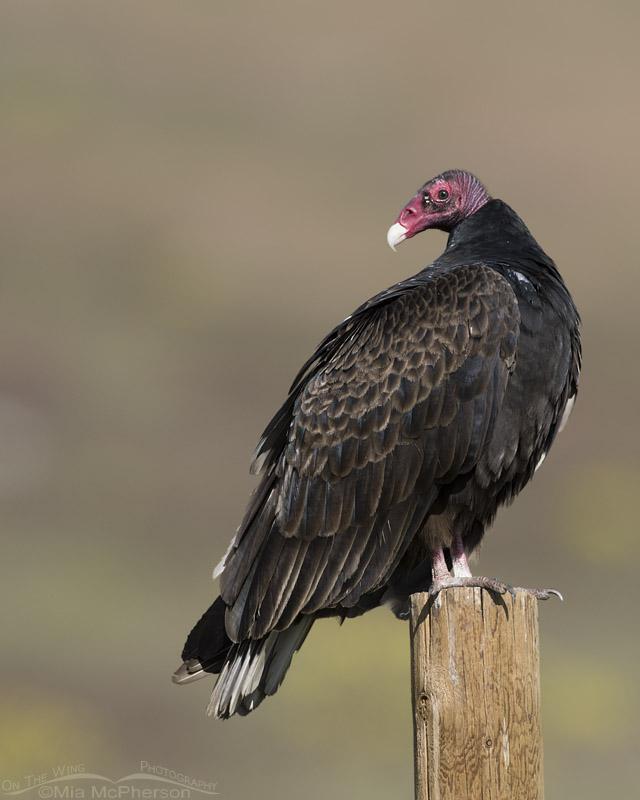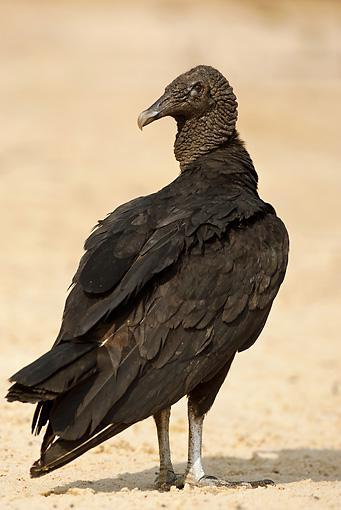The first image is the image on the left, the second image is the image on the right. Given the left and right images, does the statement "In the pair, one bird is standing on a post and the other on a flat surface." hold true? Answer yes or no. Yes. 